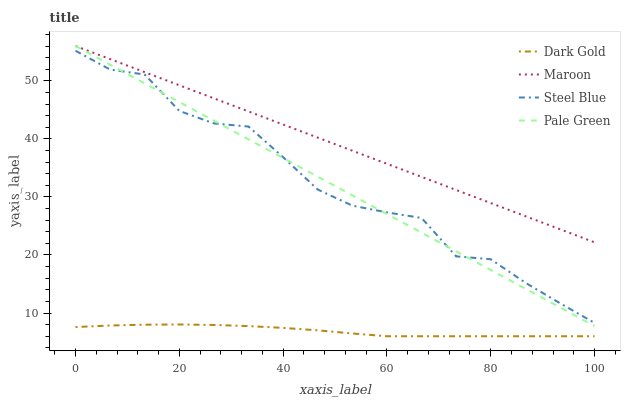Does Dark Gold have the minimum area under the curve?
Answer yes or no. Yes. Does Maroon have the maximum area under the curve?
Answer yes or no. Yes. Does Steel Blue have the minimum area under the curve?
Answer yes or no. No. Does Steel Blue have the maximum area under the curve?
Answer yes or no. No. Is Maroon the smoothest?
Answer yes or no. Yes. Is Steel Blue the roughest?
Answer yes or no. Yes. Is Steel Blue the smoothest?
Answer yes or no. No. Is Maroon the roughest?
Answer yes or no. No. Does Dark Gold have the lowest value?
Answer yes or no. Yes. Does Steel Blue have the lowest value?
Answer yes or no. No. Does Maroon have the highest value?
Answer yes or no. Yes. Does Steel Blue have the highest value?
Answer yes or no. No. Is Dark Gold less than Pale Green?
Answer yes or no. Yes. Is Maroon greater than Steel Blue?
Answer yes or no. Yes. Does Pale Green intersect Steel Blue?
Answer yes or no. Yes. Is Pale Green less than Steel Blue?
Answer yes or no. No. Is Pale Green greater than Steel Blue?
Answer yes or no. No. Does Dark Gold intersect Pale Green?
Answer yes or no. No. 